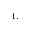<formula> <loc_0><loc_0><loc_500><loc_500>^ { 1 , }</formula> 